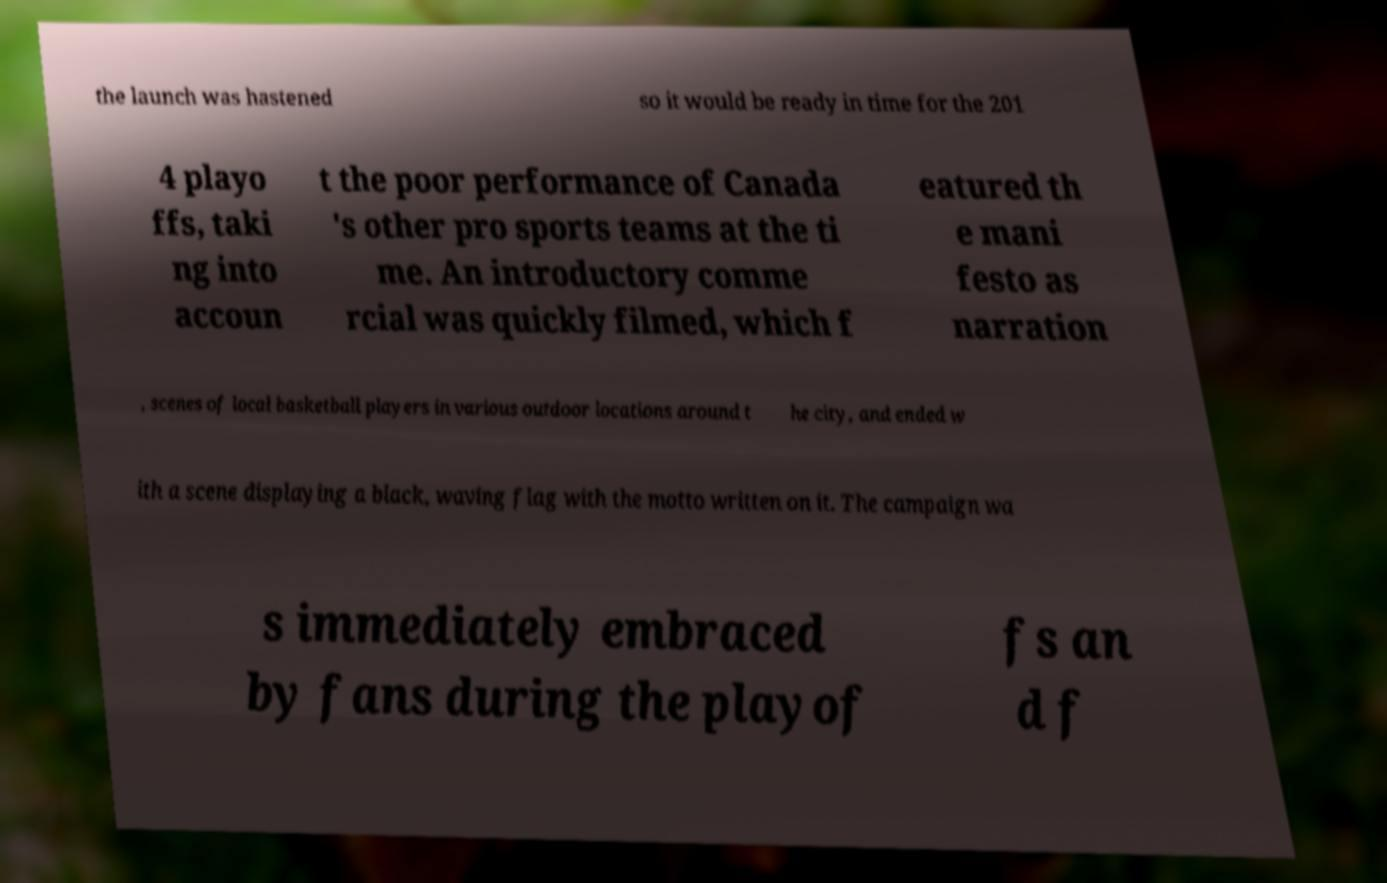I need the written content from this picture converted into text. Can you do that? the launch was hastened so it would be ready in time for the 201 4 playo ffs, taki ng into accoun t the poor performance of Canada 's other pro sports teams at the ti me. An introductory comme rcial was quickly filmed, which f eatured th e mani festo as narration , scenes of local basketball players in various outdoor locations around t he city, and ended w ith a scene displaying a black, waving flag with the motto written on it. The campaign wa s immediately embraced by fans during the playof fs an d f 